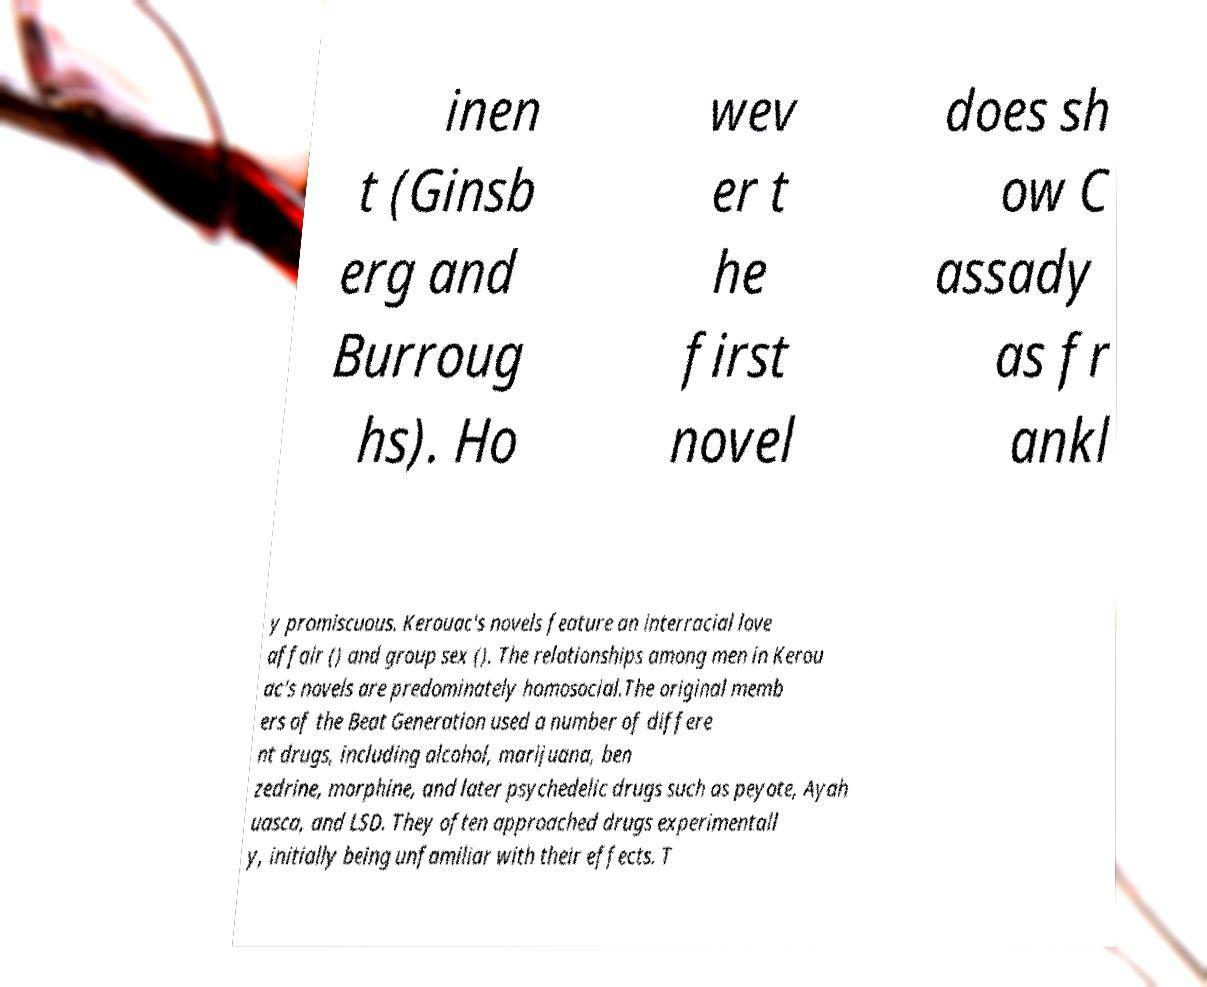Could you assist in decoding the text presented in this image and type it out clearly? inen t (Ginsb erg and Burroug hs). Ho wev er t he first novel does sh ow C assady as fr ankl y promiscuous. Kerouac's novels feature an interracial love affair () and group sex (). The relationships among men in Kerou ac's novels are predominately homosocial.The original memb ers of the Beat Generation used a number of differe nt drugs, including alcohol, marijuana, ben zedrine, morphine, and later psychedelic drugs such as peyote, Ayah uasca, and LSD. They often approached drugs experimentall y, initially being unfamiliar with their effects. T 